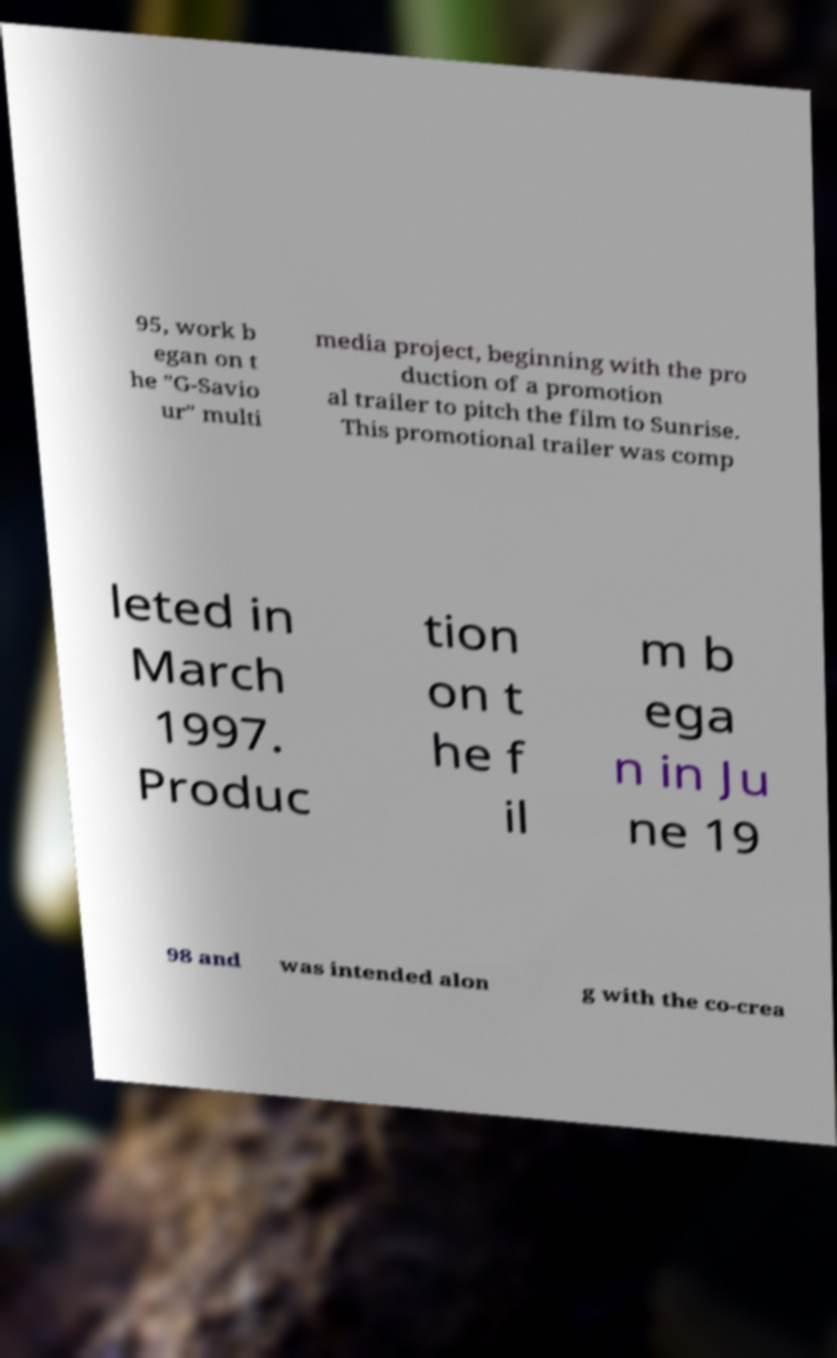What messages or text are displayed in this image? I need them in a readable, typed format. 95, work b egan on t he "G-Savio ur" multi media project, beginning with the pro duction of a promotion al trailer to pitch the film to Sunrise. This promotional trailer was comp leted in March 1997. Produc tion on t he f il m b ega n in Ju ne 19 98 and was intended alon g with the co-crea 